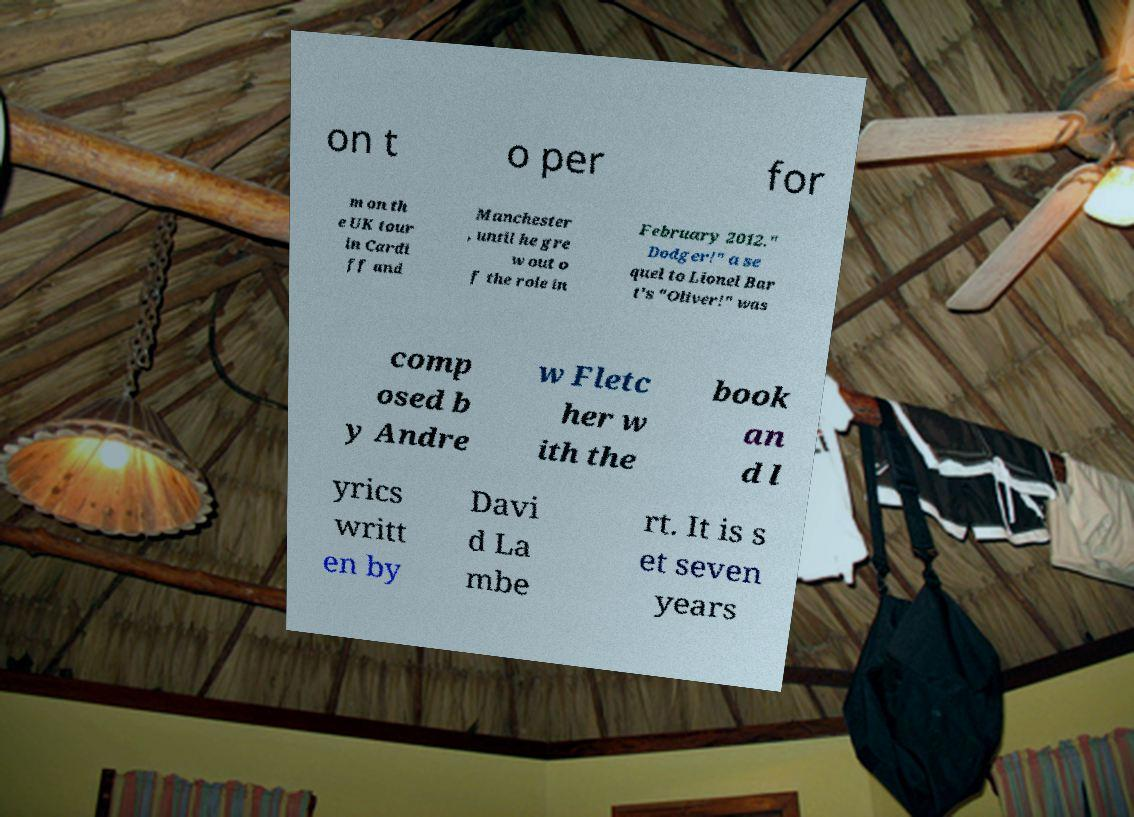Please identify and transcribe the text found in this image. on t o per for m on th e UK tour in Cardi ff and Manchester , until he gre w out o f the role in February 2012." Dodger!" a se quel to Lionel Bar t's "Oliver!" was comp osed b y Andre w Fletc her w ith the book an d l yrics writt en by Davi d La mbe rt. It is s et seven years 